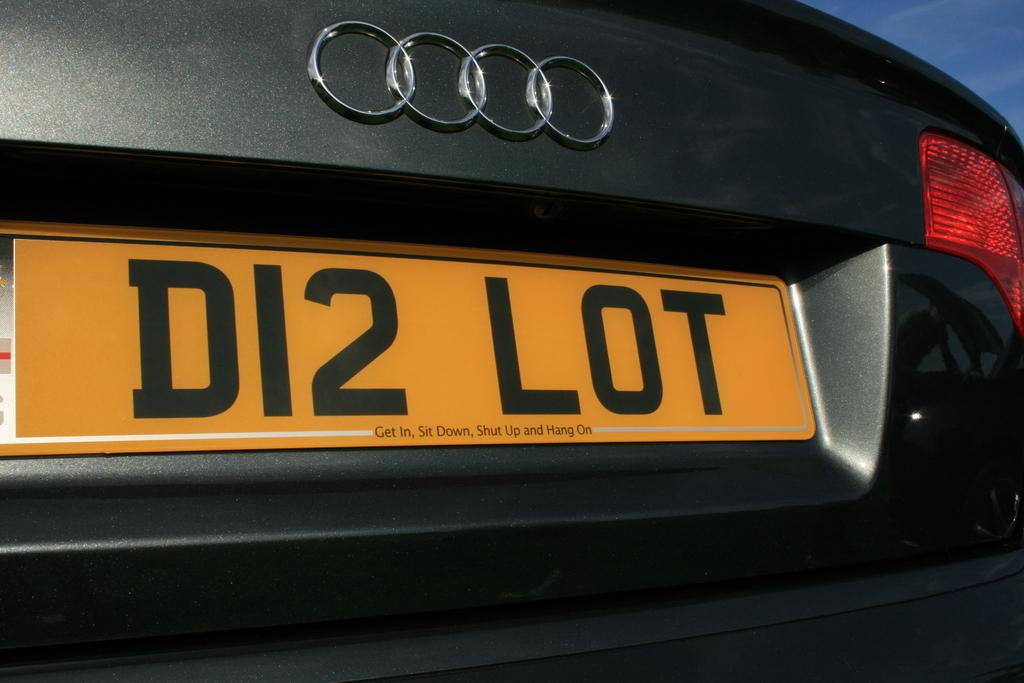<image>
Create a compact narrative representing the image presented. a license plate with the word lot on it 